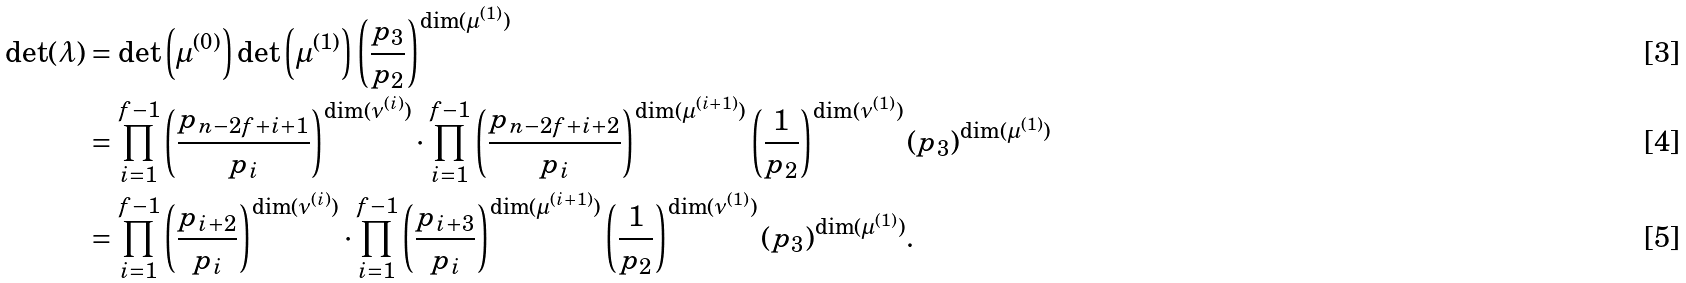Convert formula to latex. <formula><loc_0><loc_0><loc_500><loc_500>\det ( \lambda ) & = \det \left ( \mu ^ { ( 0 ) } \right ) \det \left ( \mu ^ { ( 1 ) } \right ) \left ( \frac { p _ { 3 } } { p _ { 2 } } \right ) ^ { \dim ( \mu ^ { ( 1 ) } ) } \\ & = \prod _ { i = 1 } ^ { f - 1 } \left ( \frac { p _ { n - 2 f + i + 1 } } { p _ { i } } \right ) ^ { \dim ( \nu ^ { ( i ) } ) } \cdot \prod _ { i = 1 } ^ { f - 1 } \left ( \frac { p _ { n - 2 f + i + 2 } } { p _ { i } } \right ) ^ { \dim ( \mu ^ { ( i + 1 ) } ) } \left ( \frac { 1 } { p _ { 2 } } \right ) ^ { \dim ( \nu ^ { ( 1 ) } ) } ( p _ { 3 } ) ^ { \dim ( \mu ^ { ( 1 ) } ) } \\ & = \prod _ { i = 1 } ^ { f - 1 } \left ( \frac { p _ { i + 2 } } { p _ { i } } \right ) ^ { \dim ( \nu ^ { ( i ) } ) } \cdot \prod _ { i = 1 } ^ { f - 1 } \left ( \frac { p _ { i + 3 } } { p _ { i } } \right ) ^ { \dim ( \mu ^ { ( i + 1 ) } ) } \left ( \frac { 1 } { p _ { 2 } } \right ) ^ { \dim ( \nu ^ { ( 1 ) } ) } ( p _ { 3 } ) ^ { \dim ( \mu ^ { ( 1 ) } ) } .</formula> 